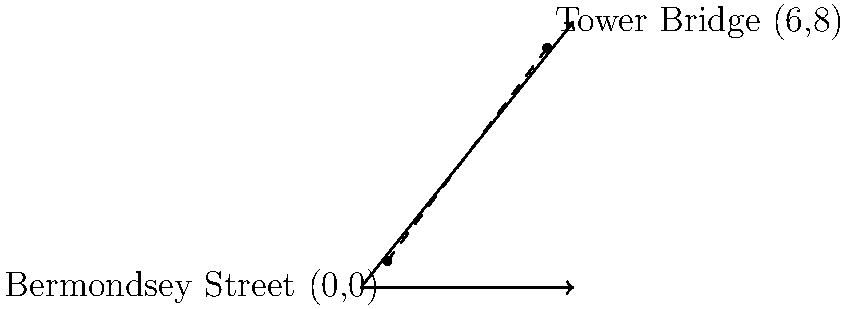As a new artist in Bermondsey, you're planning to create a piece that connects two iconic locations: Bermondsey Street and Tower Bridge. On a coordinate plane where Bermondsey Street is at (0,0) and Tower Bridge is at (6,8), calculate the straight-line distance between these two points. Round your answer to the nearest tenth of a unit. To find the distance between two points, we can use the distance formula:

$$d = \sqrt{(x_2 - x_1)^2 + (y_2 - y_1)^2}$$

Where $(x_1, y_1)$ is the coordinate of the first point and $(x_2, y_2)$ is the coordinate of the second point.

Given:
- Bermondsey Street: $(0,0)$
- Tower Bridge: $(6,8)$

Let's plug these into the formula:

$$d = \sqrt{(6 - 0)^2 + (8 - 0)^2}$$

Simplify:
$$d = \sqrt{6^2 + 8^2}$$
$$d = \sqrt{36 + 64}$$
$$d = \sqrt{100}$$
$$d = 10$$

The exact distance is 10 units. Since we're asked to round to the nearest tenth, the answer remains 10.0 units.
Answer: 10.0 units 